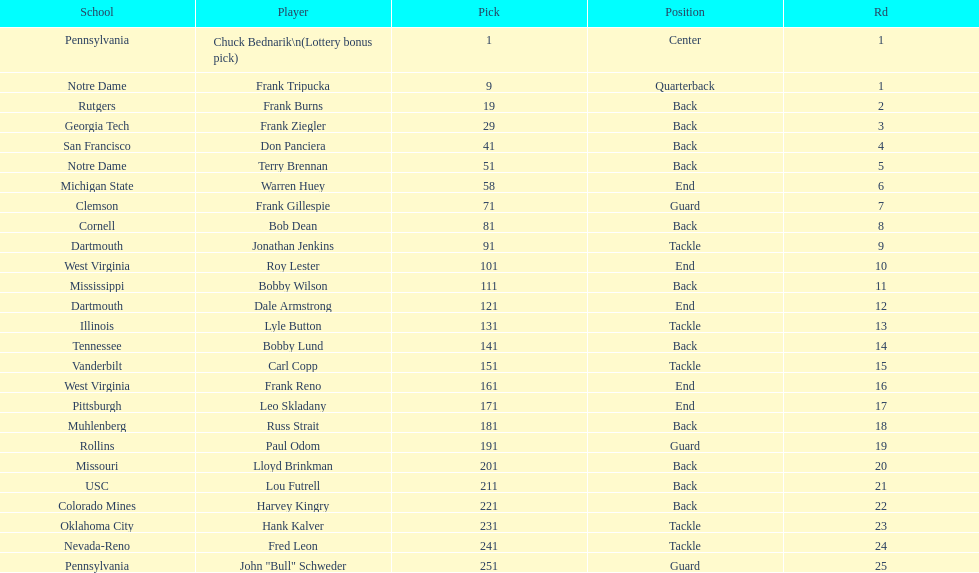How many draft picks were between frank tripucka and dale armstrong? 10. 